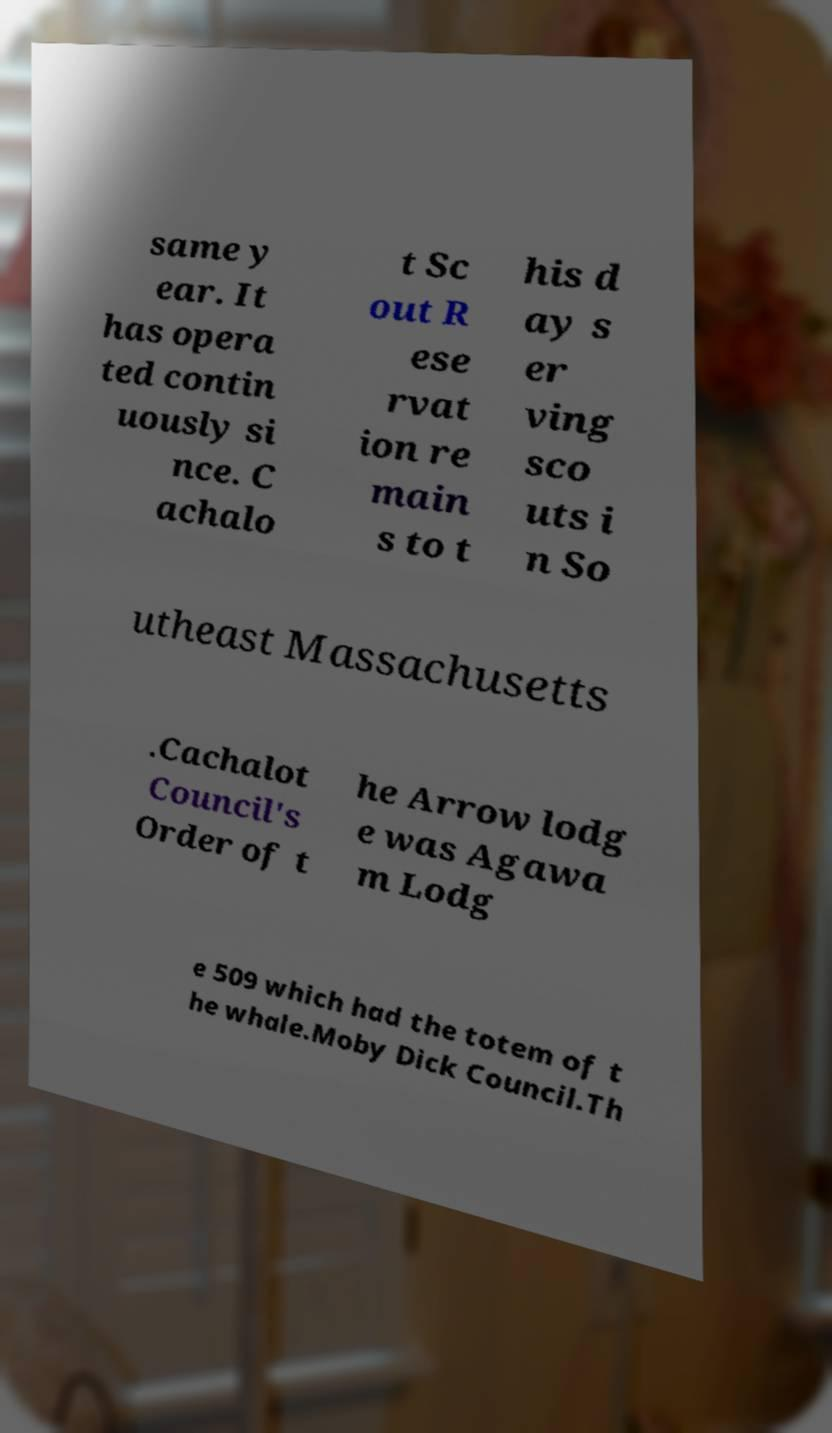Can you read and provide the text displayed in the image?This photo seems to have some interesting text. Can you extract and type it out for me? same y ear. It has opera ted contin uously si nce. C achalo t Sc out R ese rvat ion re main s to t his d ay s er ving sco uts i n So utheast Massachusetts .Cachalot Council's Order of t he Arrow lodg e was Agawa m Lodg e 509 which had the totem of t he whale.Moby Dick Council.Th 